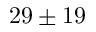<formula> <loc_0><loc_0><loc_500><loc_500>2 9 \pm 1 9</formula> 